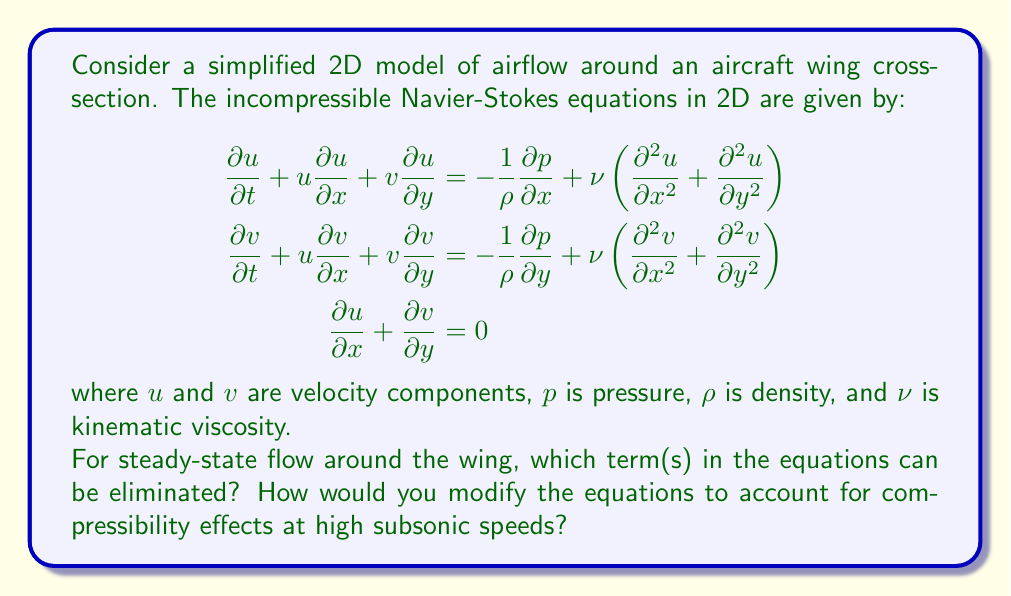Can you solve this math problem? To answer this question, we need to consider the physical meaning of each term in the Navier-Stokes equations and how they relate to steady-state flow and compressibility:

1. Steady-state flow:
   In steady-state conditions, the flow properties do not change with time. This means that all time derivatives can be eliminated from the equations. The terms that can be eliminated are:

   $$\frac{\partial u}{\partial t} \text{ and } \frac{\partial v}{\partial t}$$

   The modified steady-state equations become:

   $$\begin{aligned}
   u\frac{\partial u}{\partial x} + v\frac{\partial u}{\partial y} &= -\frac{1}{\rho}\frac{\partial p}{\partial x} + \nu\left(\frac{\partial^2 u}{\partial x^2} + \frac{\partial^2 u}{\partial y^2}\right) \\
   u\frac{\partial v}{\partial x} + v\frac{\partial v}{\partial y} &= -\frac{1}{\rho}\frac{\partial p}{\partial y} + \nu\left(\frac{\partial^2 v}{\partial x^2} + \frac{\partial^2 v}{\partial y^2}\right) \\
   \frac{\partial u}{\partial x} + \frac{\partial v}{\partial y} &= 0
   \end{aligned}$$

2. Compressibility effects:
   To account for compressibility effects at high subsonic speeds, we need to make several modifications:

   a. Include the energy equation:
      $$\rho c_p \left(\frac{\partial T}{\partial t} + u\frac{\partial T}{\partial x} + v\frac{\partial T}{\partial y}\right) = k\left(\frac{\partial^2 T}{\partial x^2} + \frac{\partial^2 T}{\partial y^2}\right) + \Phi$$
      where $T$ is temperature, $c_p$ is specific heat at constant pressure, $k$ is thermal conductivity, and $\Phi$ is the dissipation function.

   b. Use the ideal gas law to relate density, pressure, and temperature:
      $$p = \rho R T$$
      where $R$ is the specific gas constant.

   c. Allow density to vary in the continuity equation:
      $$\frac{\partial \rho}{\partial t} + \frac{\partial (\rho u)}{\partial x} + \frac{\partial (\rho v)}{\partial y} = 0$$

   d. Include variable density in the momentum equations:
      $$\begin{aligned}
      \rho\left(\frac{\partial u}{\partial t} + u\frac{\partial u}{\partial x} + v\frac{\partial u}{\partial y}\right) &= -\frac{\partial p}{\partial x} + \frac{\partial}{\partial x}\left(\mu\frac{\partial u}{\partial x}\right) + \frac{\partial}{\partial y}\left(\mu\frac{\partial u}{\partial y}\right) \\
      \rho\left(\frac{\partial v}{\partial t} + u\frac{\partial v}{\partial x} + v\frac{\partial v}{\partial y}\right) &= -\frac{\partial p}{\partial y} + \frac{\partial}{\partial x}\left(\mu\frac{\partial v}{\partial x}\right) + \frac{\partial}{\partial y}\left(\mu\frac{\partial v}{\partial y}\right)
      \end{aligned}$$
      where $\mu$ is the dynamic viscosity.

   e. Consider the Mach number in the simulation to determine the degree of compressibility effects.

These modifications allow for a more accurate representation of the airflow around aircraft surfaces at high subsonic speeds, accounting for the compressibility effects that become significant as the flow velocity approaches the speed of sound.
Answer: For steady-state flow, the time derivative terms $\frac{\partial u}{\partial t}$ and $\frac{\partial v}{\partial t}$ can be eliminated from the Navier-Stokes equations.

To account for compressibility effects at high subsonic speeds:
1. Include the energy equation
2. Use the ideal gas law
3. Allow for variable density in the continuity equation
4. Include variable density in the momentum equations
5. Consider the Mach number to determine the degree of compressibility effects 